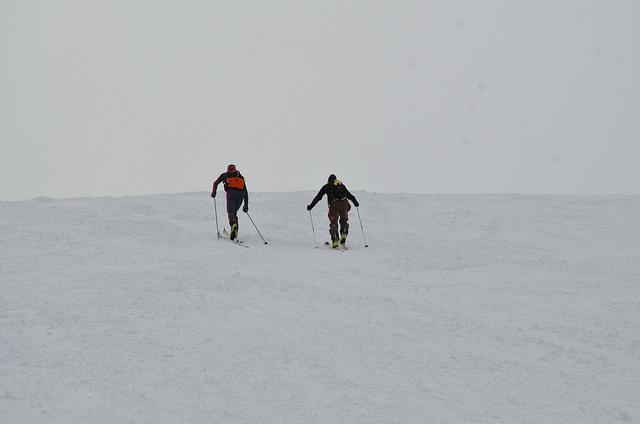How many chairs are there?
Give a very brief answer. 0. 